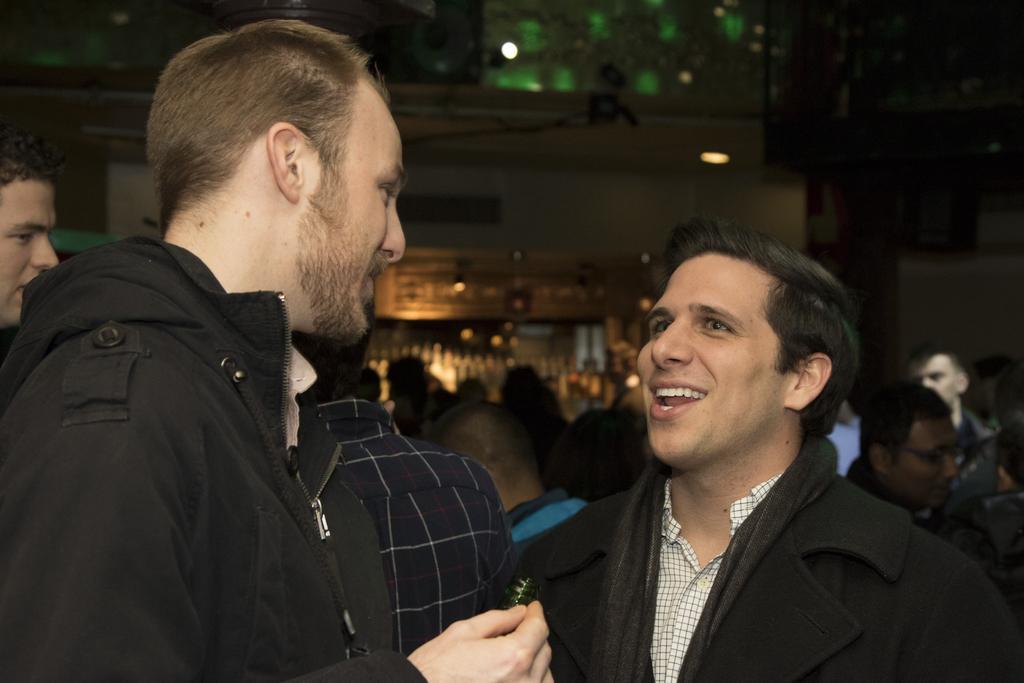Could you give a brief overview of what you see in this image? In the left side a man is there, he wore a black color coat and looking at this person. In the right side a man is talking with him and also smiling. 